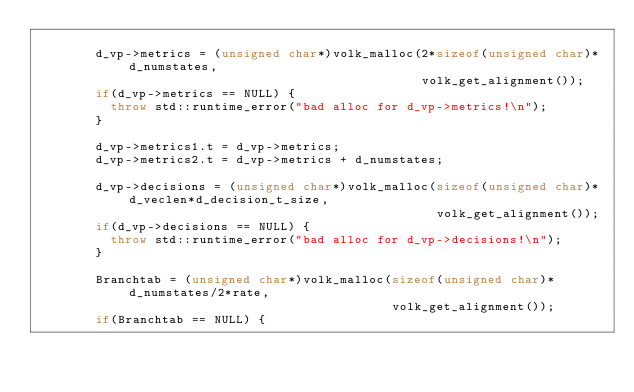Convert code to text. <code><loc_0><loc_0><loc_500><loc_500><_C++_>
        d_vp->metrics = (unsigned char*)volk_malloc(2*sizeof(unsigned char)*d_numstates,
                                                    volk_get_alignment());
        if(d_vp->metrics == NULL) {
          throw std::runtime_error("bad alloc for d_vp->metrics!\n");
        }

        d_vp->metrics1.t = d_vp->metrics;
        d_vp->metrics2.t = d_vp->metrics + d_numstates;

        d_vp->decisions = (unsigned char*)volk_malloc(sizeof(unsigned char)*d_veclen*d_decision_t_size,
                                                      volk_get_alignment());
        if(d_vp->decisions == NULL) {
          throw std::runtime_error("bad alloc for d_vp->decisions!\n");
        }

        Branchtab = (unsigned char*)volk_malloc(sizeof(unsigned char)*d_numstates/2*rate,
                                                volk_get_alignment());
        if(Branchtab == NULL) {</code> 